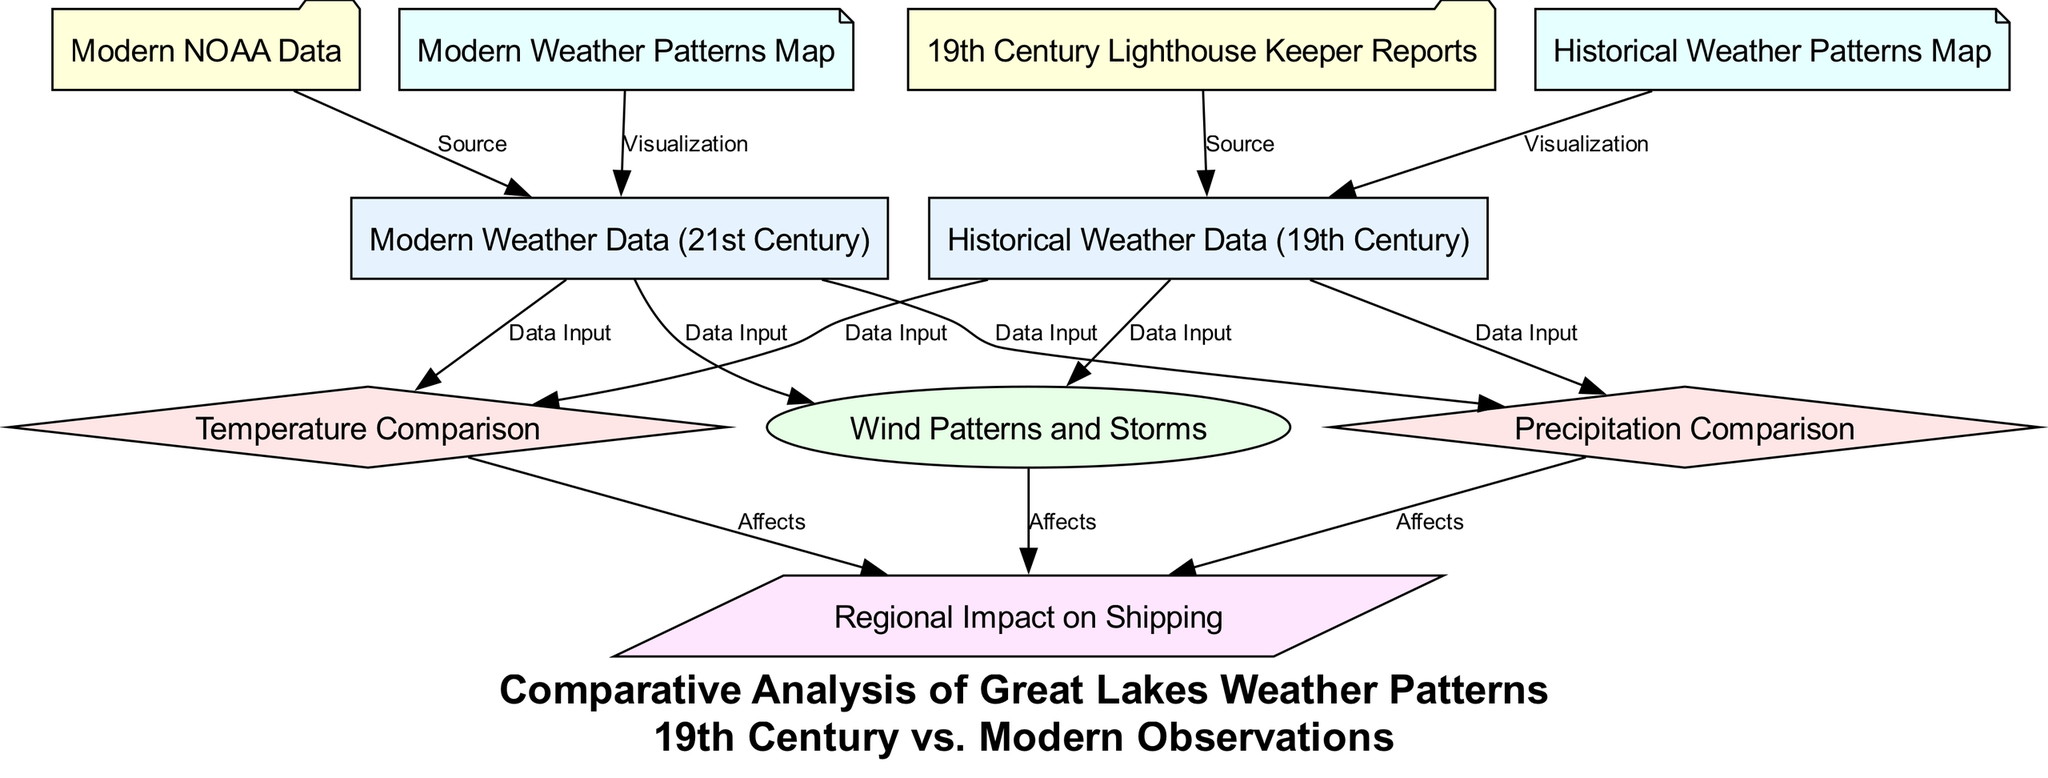What compares the temperature between historical and modern data? The diagram indicates that both historical weather data and modern weather data are connected to the temperature comparison node. This shows that the temperature comparison focuses on data input from both historical and contemporary perspectives.
Answer: Temperature Comparison How many nodes are there in the diagram? By counting all the unique nodes specified in the data section of the diagram structure, there are a total of 10 nodes representing different aspects of the weather data comparison.
Answer: 10 Which resource supplies historical weather data? The edge from the "19th Century Lighthouse Keeper Reports" node to the "Historical Weather Data (19th Century)" node indicates that the reports from lighthouse keepers are the sources of the historical weather data.
Answer: 19th Century Lighthouse Keeper Reports What is the outcome of precipitation comparison on regional impact? The diagram illustrates that the precipitation comparison has a direct connection to the regional impact node, indicating that changes in precipitation can affect shipping and other regional factors.
Answer: Affects Which maps are provided for visualization in the diagram? The diagram contains two specific nodes for visualization: "Historical Weather Patterns Map" and "Modern Weather Patterns Map." These maps represent the weather patterns from the respective time periods for visual comparative analysis.
Answer: Historical Weather Patterns Map, Modern Weather Patterns Map What type of weather patterns does the wind patterns node analyze? The "Wind Patterns and Storms" node represents the study of patterns related to wind and storm occurrences, linking it to both the historical and modern weather data. It plays a crucial role in understanding how wind impacts weather in the Great Lakes region.
Answer: Wind Patterns and Storms Which modern resource provides data for the weather analysis? The "NOAA_data" node is connected to the "Modern Weather Data (21st Century)" node, indicating that the modern weather data source is provided by NOAA (National Oceanic and Atmospheric Administration).
Answer: NOAA_data How do modern weather patterns relate to shipping? The diagram shows that both the temperature comparison, precipitation comparison, and wind patterns ultimately connect to regional impact, which implies that weather patterns have implications for shipping activities in the region today.
Answer: Regional Impact on Shipping 